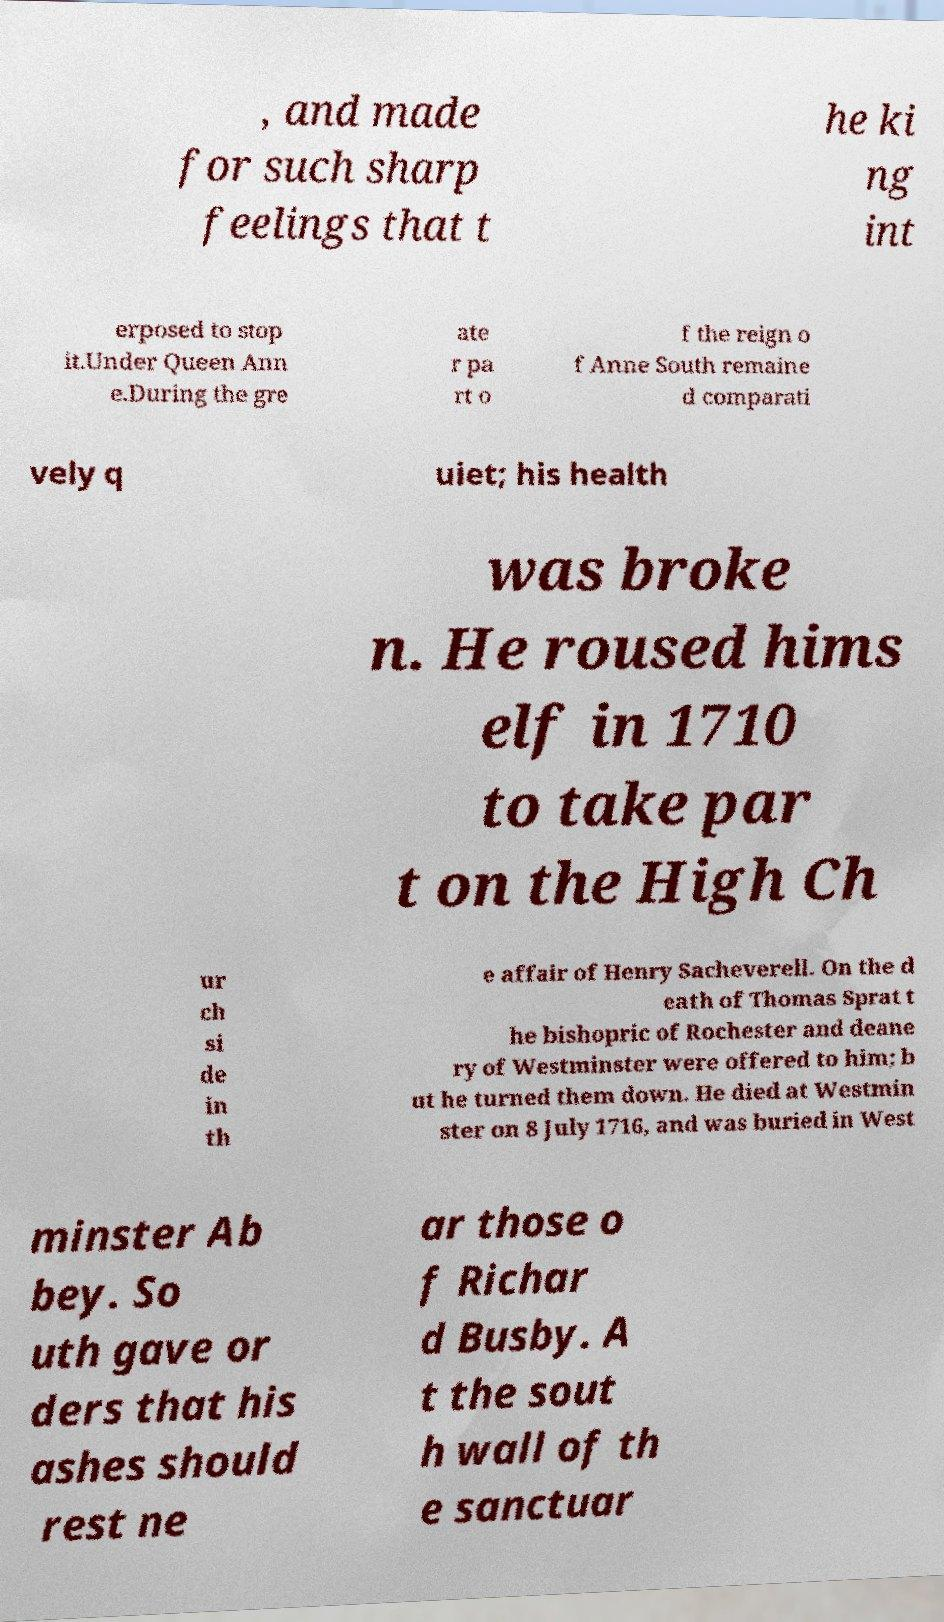Please identify and transcribe the text found in this image. , and made for such sharp feelings that t he ki ng int erposed to stop it.Under Queen Ann e.During the gre ate r pa rt o f the reign o f Anne South remaine d comparati vely q uiet; his health was broke n. He roused hims elf in 1710 to take par t on the High Ch ur ch si de in th e affair of Henry Sacheverell. On the d eath of Thomas Sprat t he bishopric of Rochester and deane ry of Westminster were offered to him; b ut he turned them down. He died at Westmin ster on 8 July 1716, and was buried in West minster Ab bey. So uth gave or ders that his ashes should rest ne ar those o f Richar d Busby. A t the sout h wall of th e sanctuar 